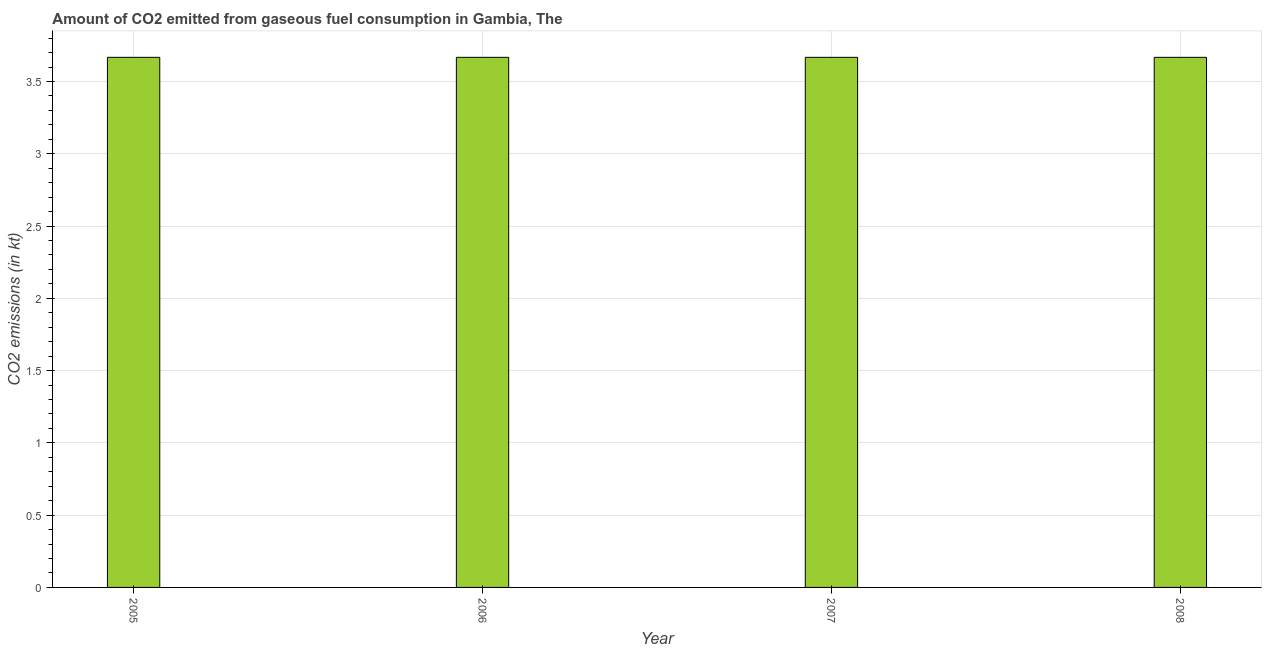Does the graph contain any zero values?
Your response must be concise. No. What is the title of the graph?
Give a very brief answer. Amount of CO2 emitted from gaseous fuel consumption in Gambia, The. What is the label or title of the X-axis?
Your answer should be compact. Year. What is the label or title of the Y-axis?
Offer a terse response. CO2 emissions (in kt). What is the co2 emissions from gaseous fuel consumption in 2007?
Give a very brief answer. 3.67. Across all years, what is the maximum co2 emissions from gaseous fuel consumption?
Ensure brevity in your answer.  3.67. Across all years, what is the minimum co2 emissions from gaseous fuel consumption?
Your response must be concise. 3.67. In which year was the co2 emissions from gaseous fuel consumption maximum?
Keep it short and to the point. 2005. What is the sum of the co2 emissions from gaseous fuel consumption?
Ensure brevity in your answer.  14.67. What is the average co2 emissions from gaseous fuel consumption per year?
Your answer should be very brief. 3.67. What is the median co2 emissions from gaseous fuel consumption?
Offer a very short reply. 3.67. In how many years, is the co2 emissions from gaseous fuel consumption greater than 0.6 kt?
Make the answer very short. 4. Is the co2 emissions from gaseous fuel consumption in 2006 less than that in 2008?
Provide a short and direct response. No. Is the difference between the co2 emissions from gaseous fuel consumption in 2005 and 2006 greater than the difference between any two years?
Offer a very short reply. Yes. What is the difference between the highest and the lowest co2 emissions from gaseous fuel consumption?
Provide a short and direct response. 0. Are all the bars in the graph horizontal?
Ensure brevity in your answer.  No. Are the values on the major ticks of Y-axis written in scientific E-notation?
Ensure brevity in your answer.  No. What is the CO2 emissions (in kt) in 2005?
Your response must be concise. 3.67. What is the CO2 emissions (in kt) of 2006?
Ensure brevity in your answer.  3.67. What is the CO2 emissions (in kt) in 2007?
Ensure brevity in your answer.  3.67. What is the CO2 emissions (in kt) of 2008?
Make the answer very short. 3.67. What is the difference between the CO2 emissions (in kt) in 2005 and 2006?
Give a very brief answer. 0. What is the difference between the CO2 emissions (in kt) in 2005 and 2007?
Your response must be concise. 0. What is the difference between the CO2 emissions (in kt) in 2006 and 2007?
Keep it short and to the point. 0. What is the difference between the CO2 emissions (in kt) in 2007 and 2008?
Provide a succinct answer. 0. What is the ratio of the CO2 emissions (in kt) in 2005 to that in 2007?
Make the answer very short. 1. What is the ratio of the CO2 emissions (in kt) in 2006 to that in 2008?
Provide a short and direct response. 1. 